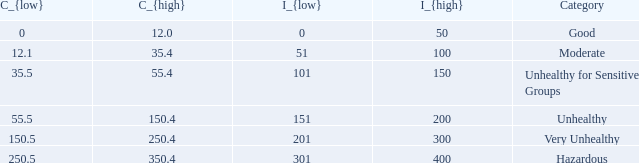0? 0.0. 